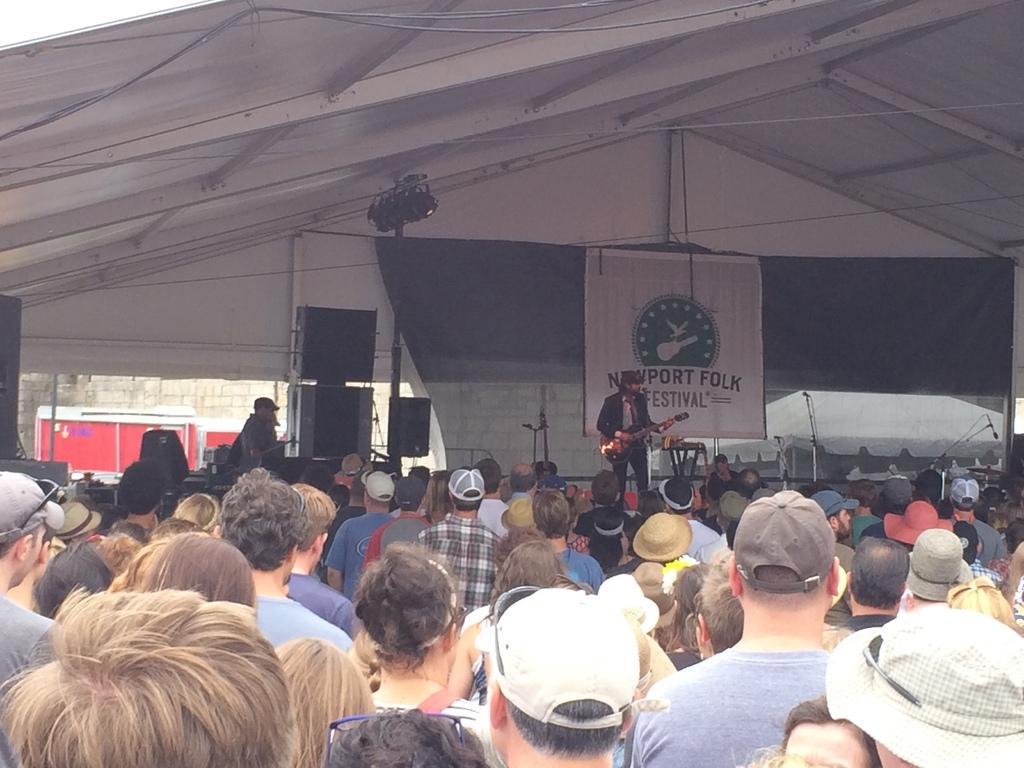Please provide a concise description of this image. At the bottom of the image, we can see so many people. In the background of the image, we can see sound boxes, stand, mics and banner. At the top of the image, we can see the wire and the roof. In the middle of the image, we can see a man is standing on the stage and playing guitar. 